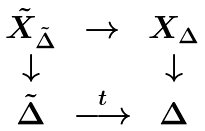Convert formula to latex. <formula><loc_0><loc_0><loc_500><loc_500>\begin{array} { c c c } \tilde { X } _ { \tilde { \Delta } } & \rightarrow & X _ { \Delta } \\ \downarrow & & \downarrow \\ \tilde { \Delta } & \overset { t } { \longrightarrow } & \Delta \end{array}</formula> 